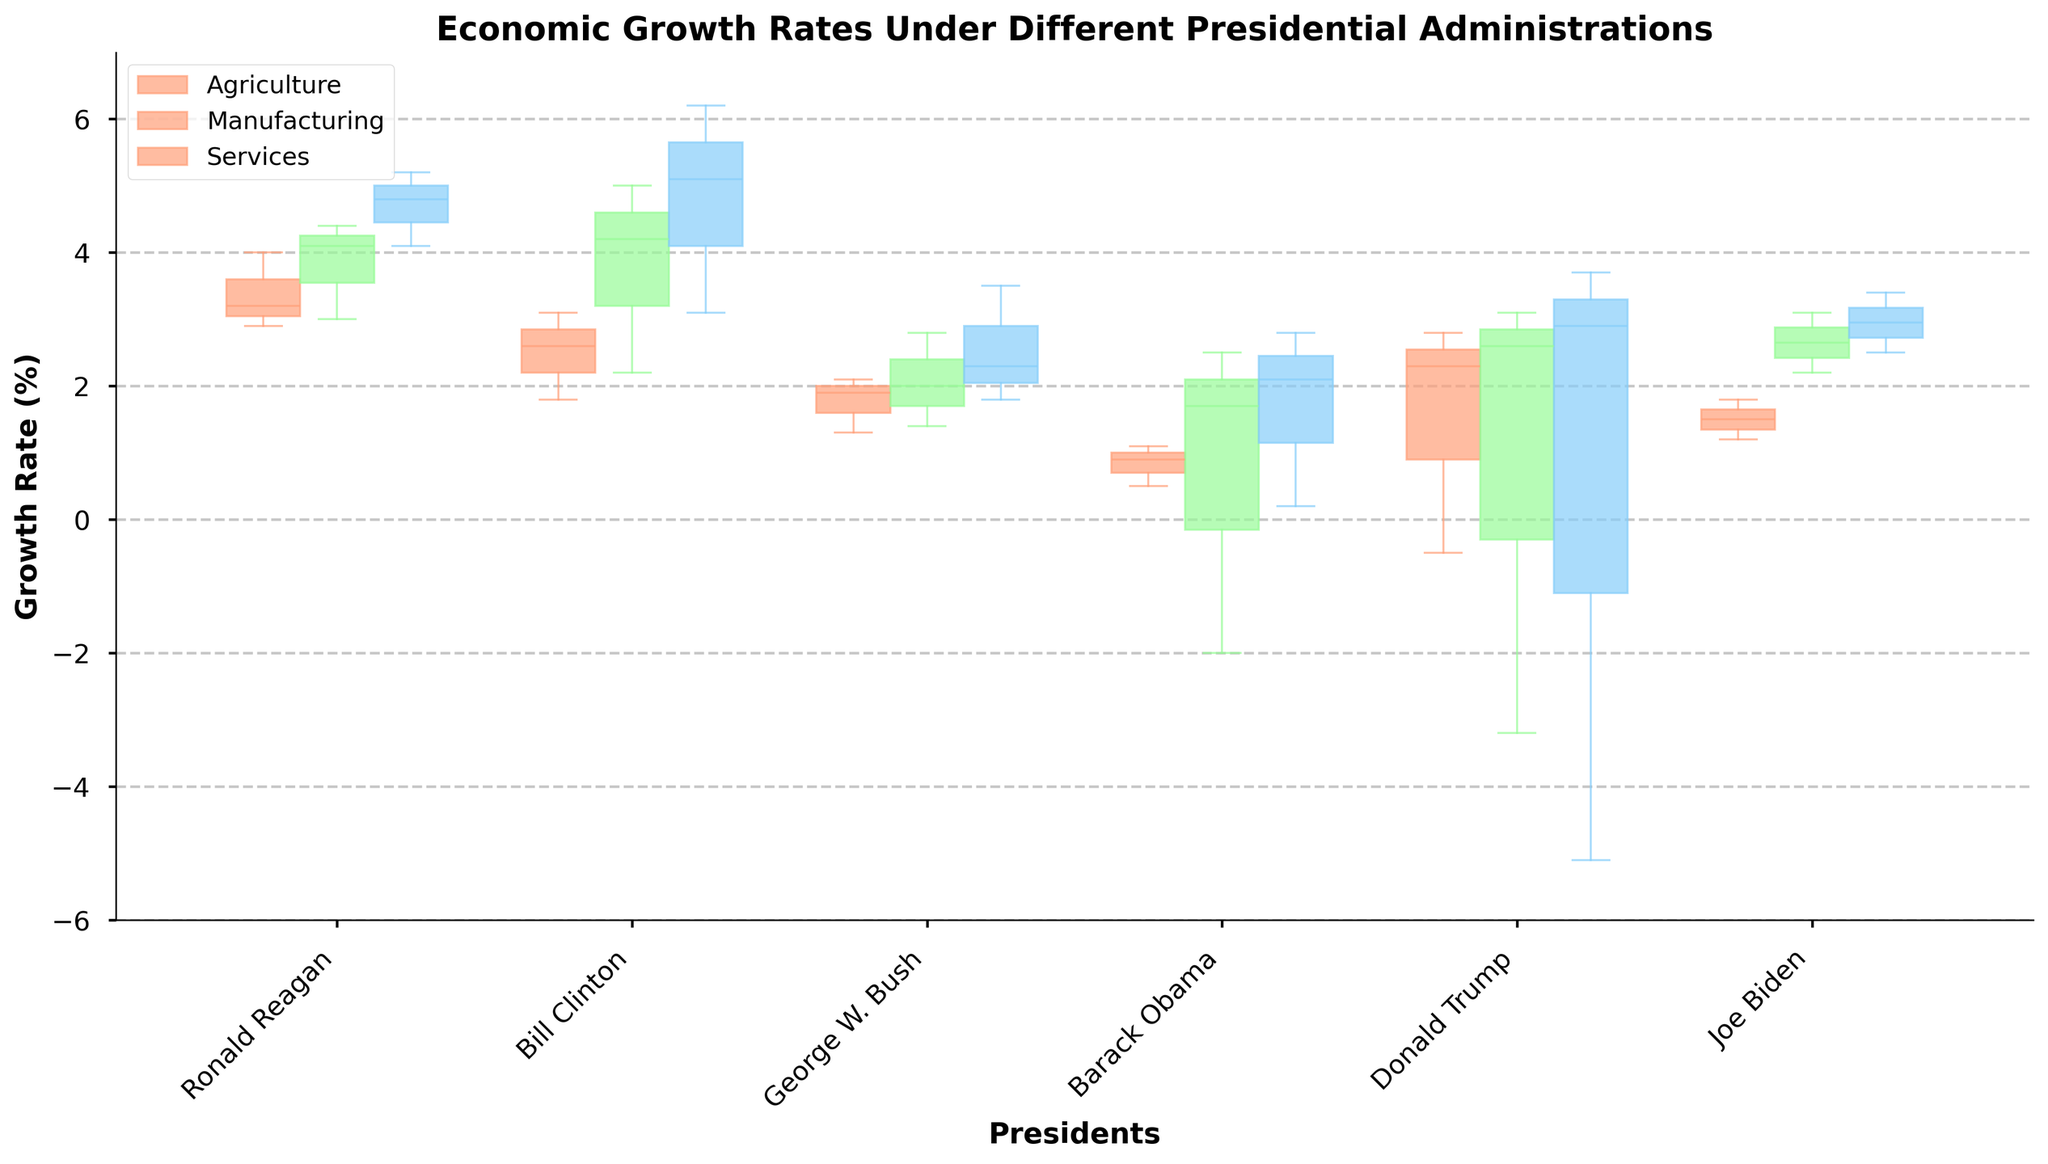What is the title of the figure? The title is displayed at the top of the figure.
Answer: Economic Growth Rates Under Different Presidential Administrations Which sector has the highest median growth rate under Ronald Reagan? In the box plots for Ronald Reagan, the median is the line inside the box. The Services sector shows the highest median growth rate.
Answer: Services What are the colors used to represent each sector? Inspect the legend in the top left corner; the colors correspond to the sectors. Agriculture is in light salmon, Manufacturing is in light green, and Services is in light blue.
Answer: Light salmon (Agriculture), light green (Manufacturing), light blue (Services) Under which president did the Services sector experience the lowest growth rate? Locate the lowest point (whisker) in the box plots for the Services sector. It occurs under Donald Trump, where the lowest value in 2020 is -5.1%.
Answer: Donald Trump Which president showed the most consistent growth rate in the Agriculture sector? The consistency can be judged by looking at the range of the box plots. Barack Obama has the smallest range (difference between the top of the box and the bottom) in the Agriculture sector.
Answer: Barack Obama During which presidential administration did Manufacturing experience the highest growth rate? Identify the highest whisker in the box plots for Manufacturing. The highest value is 5.0% in Bill Clinton's administration in 2000.
Answer: Bill Clinton Compare the median growth rates of the Services sector between Barack Obama and Donald Trump. The median is the line inside each box. For Barack Obama, it's around 2.1% (2016), for Donald Trump, the Services sector's median in 2019 is about 2.9%.
Answer: Donald Trump's is higher Which sector shows the largest variability in growth rates under George W. Bush? Variability can be measured by the spread and length (interquartile range) of the box plots. The Services sector demonstrates the largest variability in George W. Bush's term.
Answer: Services What is the average of the median growth rates in the Agriculture sector under Bill Clinton? Determine the medians from each box plot under Bill Clinton in the Agriculture sector: 1.8%, 2.6%, and 3.1%. The average is (1.8 + 2.6 + 3.1) / 3.
Answer: 2.5% Which sector showed negative growth under Donald Trump? Observing the lowest whiskers in Donald Trump's box plots, Manufacturing and Services sectors exhibit negative growth rates in 2020.
Answer: Manufacturing and Services 